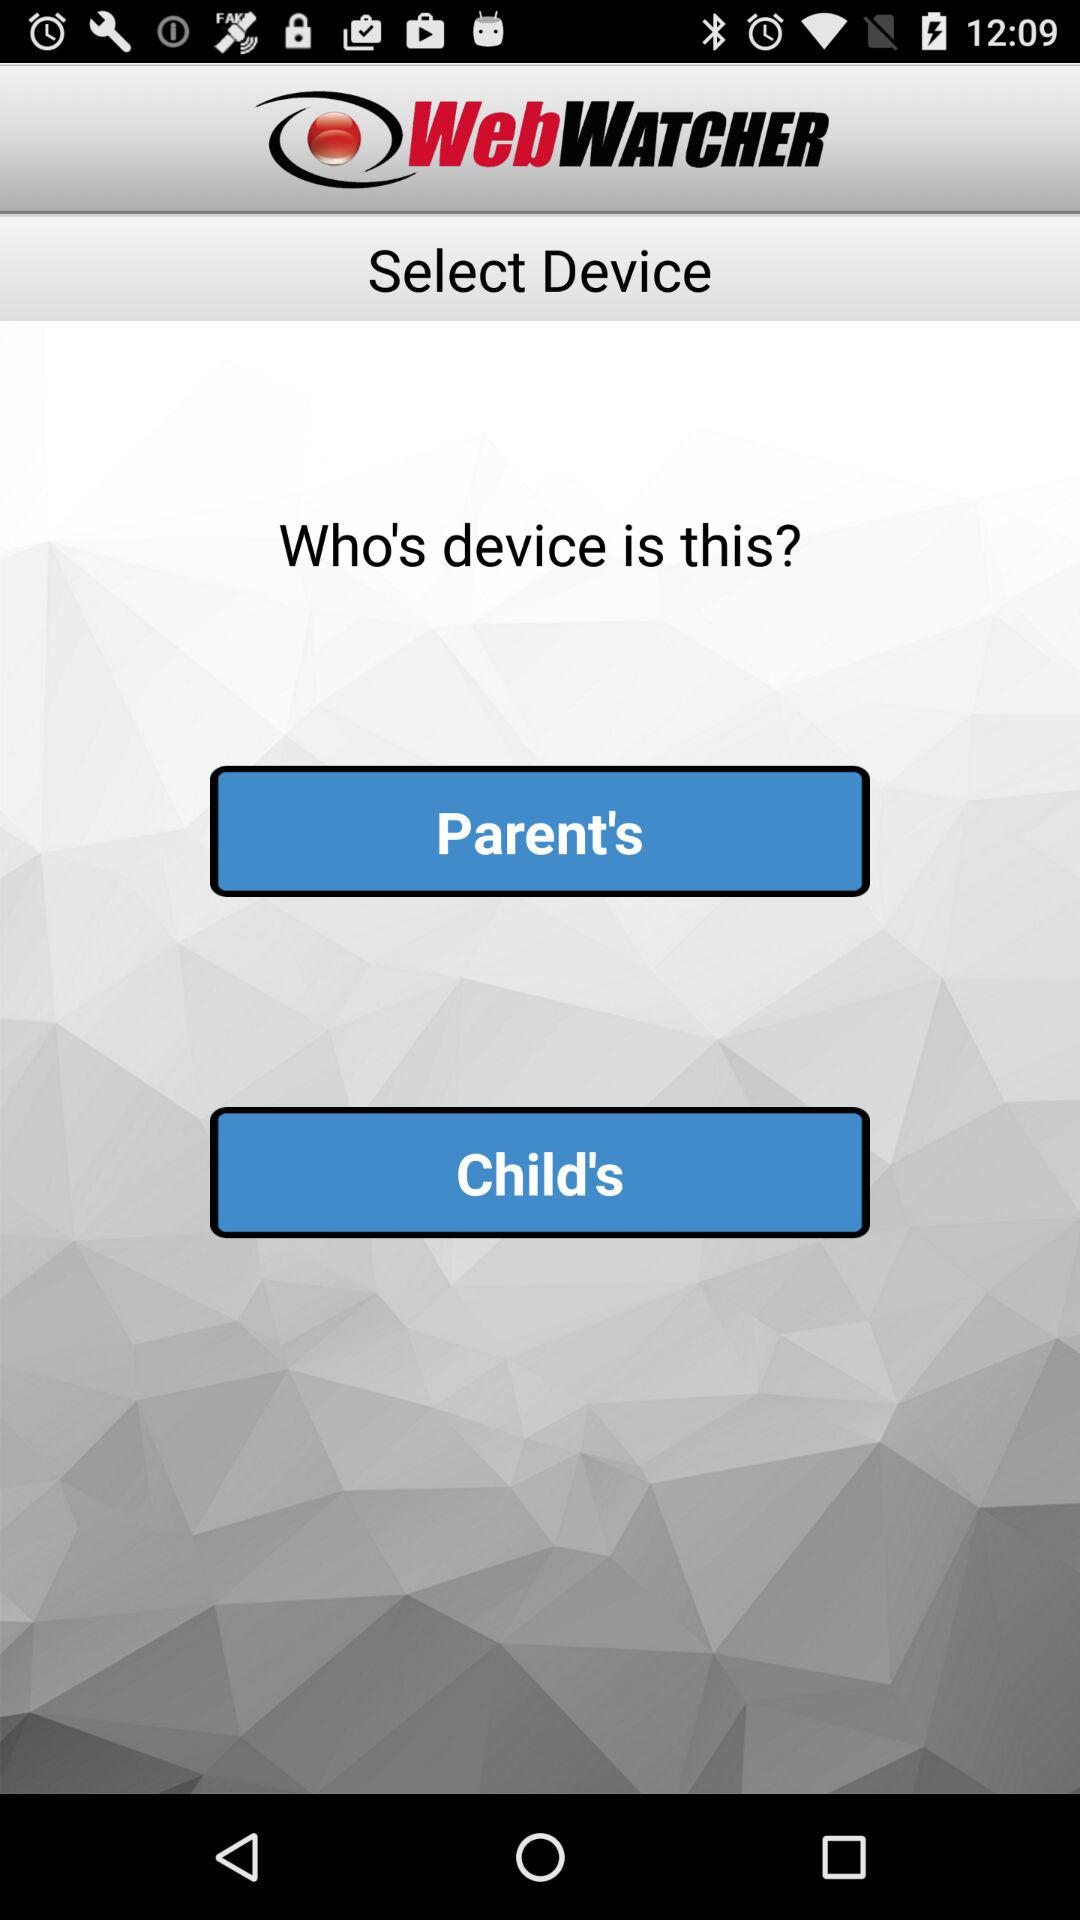Who is the owner of the device?
When the provided information is insufficient, respond with <no answer>. <no answer> 